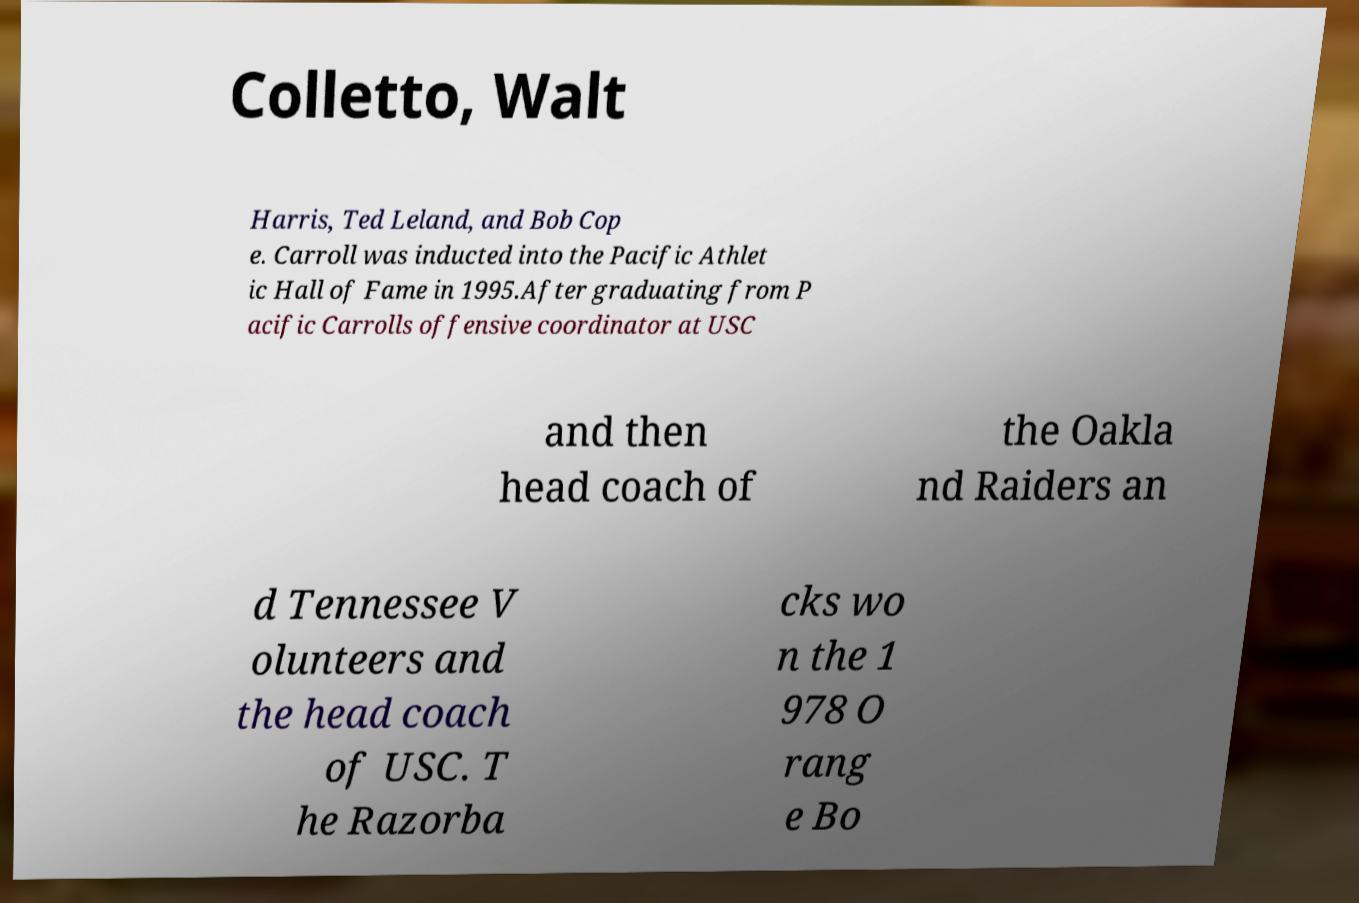For documentation purposes, I need the text within this image transcribed. Could you provide that? Colletto, Walt Harris, Ted Leland, and Bob Cop e. Carroll was inducted into the Pacific Athlet ic Hall of Fame in 1995.After graduating from P acific Carrolls offensive coordinator at USC and then head coach of the Oakla nd Raiders an d Tennessee V olunteers and the head coach of USC. T he Razorba cks wo n the 1 978 O rang e Bo 